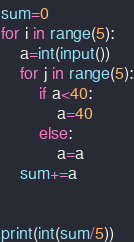<code> <loc_0><loc_0><loc_500><loc_500><_Python_>sum=0
for i in range(5):
    a=int(input())
    for j in range(5):
        if a<40:
            a=40
        else:
            a=a
    sum+=a
    

print(int(sum/5))
</code> 